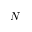<formula> <loc_0><loc_0><loc_500><loc_500>N</formula> 